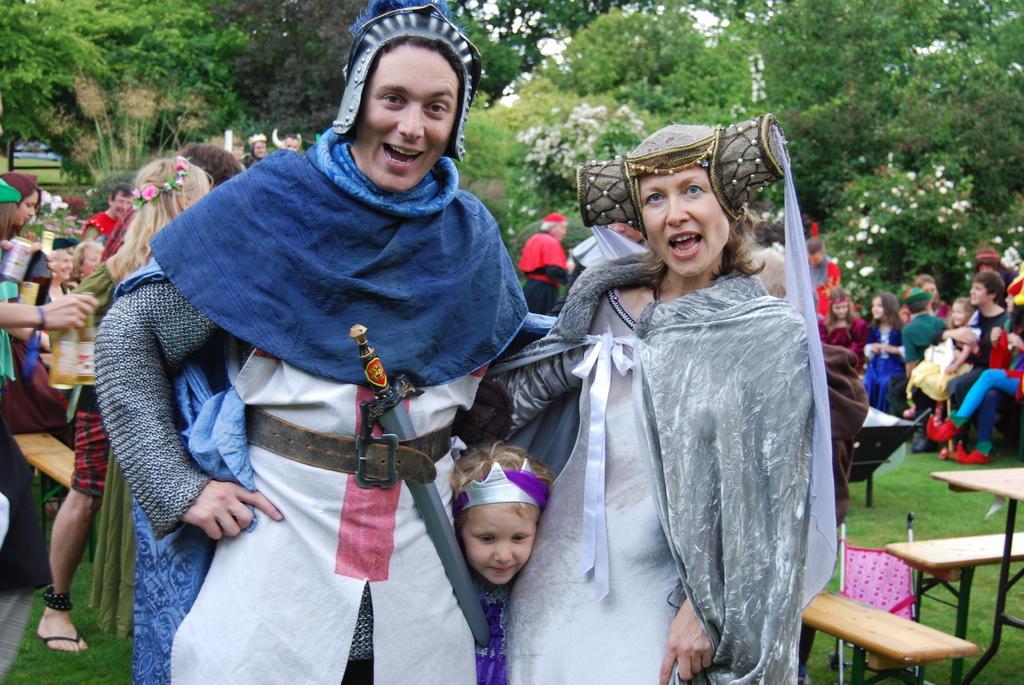How would you summarize this image in a sentence or two? In this image there is a man , woman and a girl standing by wearing a costume and in back ground there are group of persons standing and sitting in chairs, tree, flowers. 